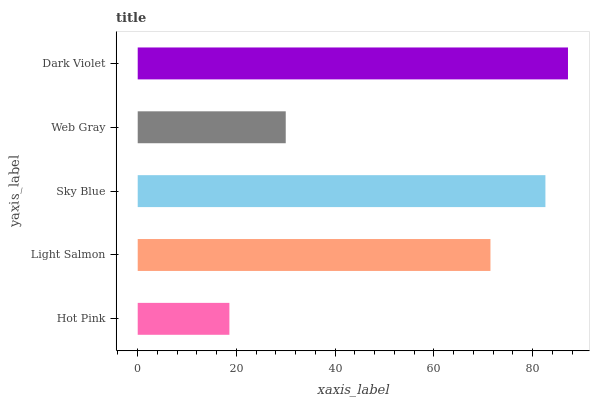Is Hot Pink the minimum?
Answer yes or no. Yes. Is Dark Violet the maximum?
Answer yes or no. Yes. Is Light Salmon the minimum?
Answer yes or no. No. Is Light Salmon the maximum?
Answer yes or no. No. Is Light Salmon greater than Hot Pink?
Answer yes or no. Yes. Is Hot Pink less than Light Salmon?
Answer yes or no. Yes. Is Hot Pink greater than Light Salmon?
Answer yes or no. No. Is Light Salmon less than Hot Pink?
Answer yes or no. No. Is Light Salmon the high median?
Answer yes or no. Yes. Is Light Salmon the low median?
Answer yes or no. Yes. Is Hot Pink the high median?
Answer yes or no. No. Is Dark Violet the low median?
Answer yes or no. No. 